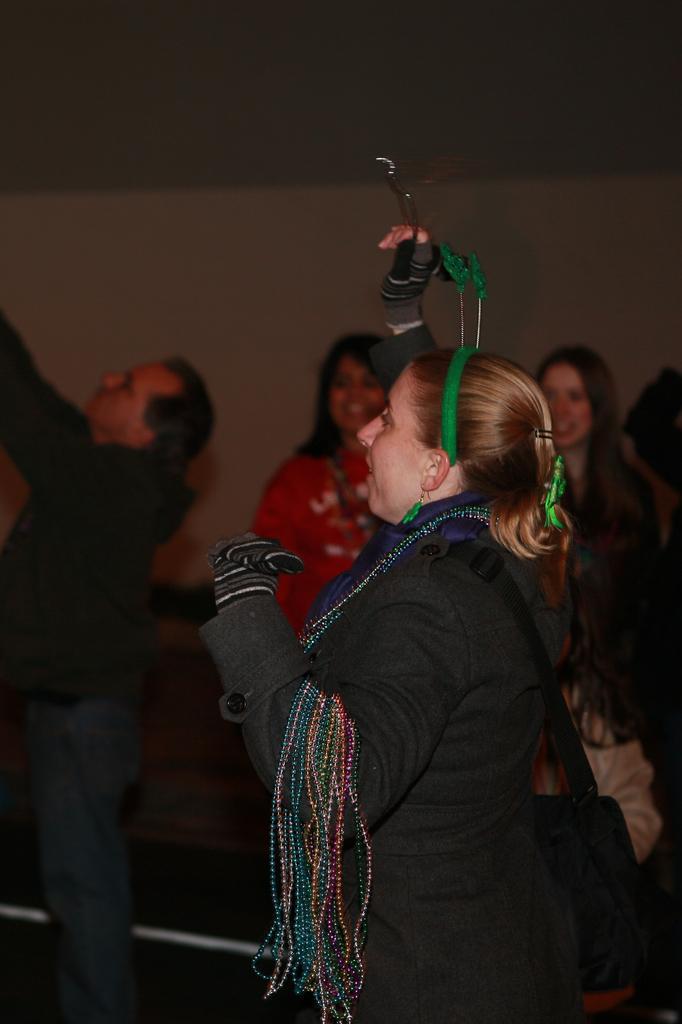In one or two sentences, can you explain what this image depicts? This picture shows a woman standing and holding something in her hand and she wore a handbag. 